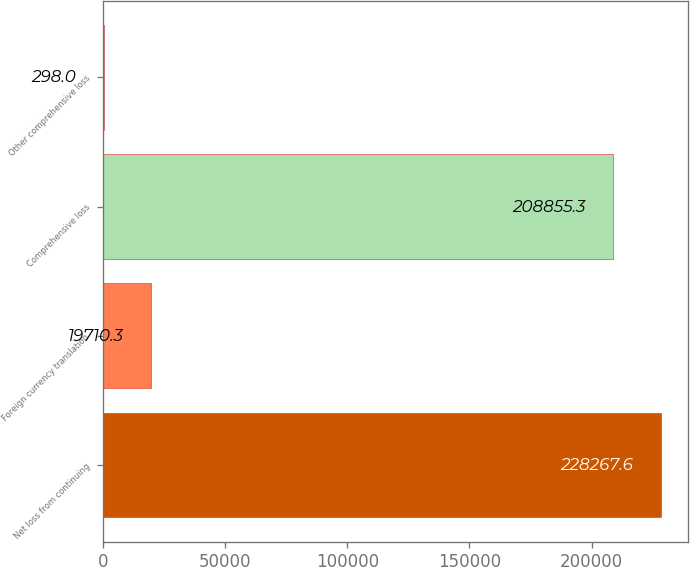Convert chart. <chart><loc_0><loc_0><loc_500><loc_500><bar_chart><fcel>Net loss from continuing<fcel>Foreign currency translation<fcel>Comprehensive loss<fcel>Other comprehensive loss<nl><fcel>228268<fcel>19710.3<fcel>208855<fcel>298<nl></chart> 